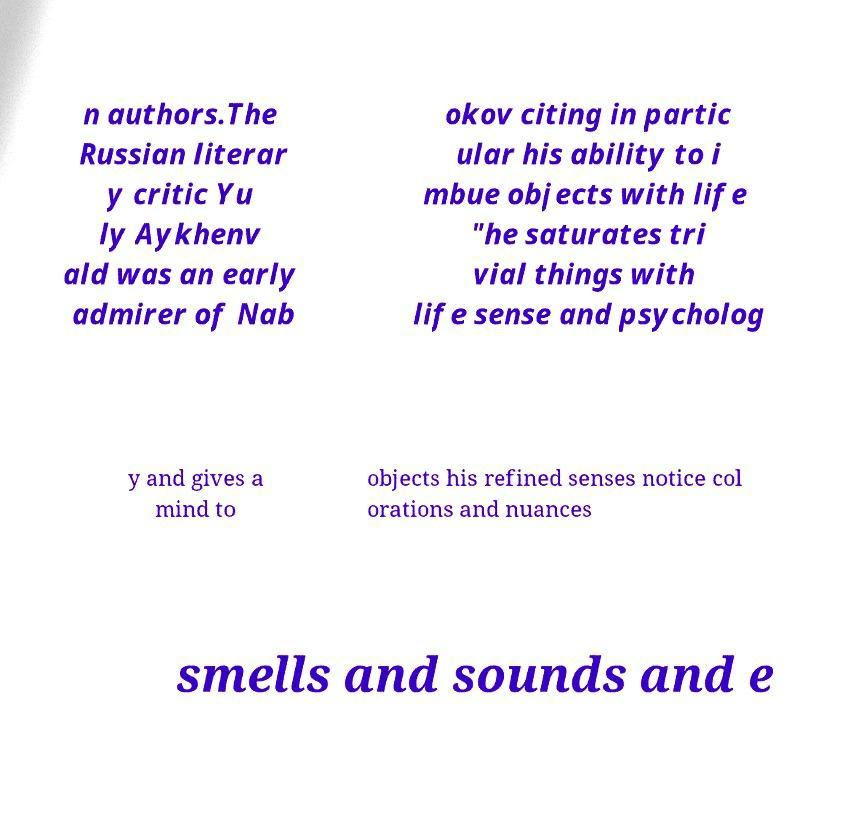Could you assist in decoding the text presented in this image and type it out clearly? n authors.The Russian literar y critic Yu ly Aykhenv ald was an early admirer of Nab okov citing in partic ular his ability to i mbue objects with life "he saturates tri vial things with life sense and psycholog y and gives a mind to objects his refined senses notice col orations and nuances smells and sounds and e 